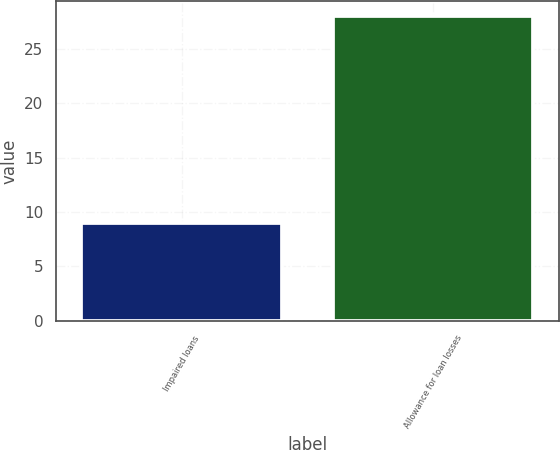<chart> <loc_0><loc_0><loc_500><loc_500><bar_chart><fcel>Impaired loans<fcel>Allowance for loan losses<nl><fcel>9<fcel>28<nl></chart> 